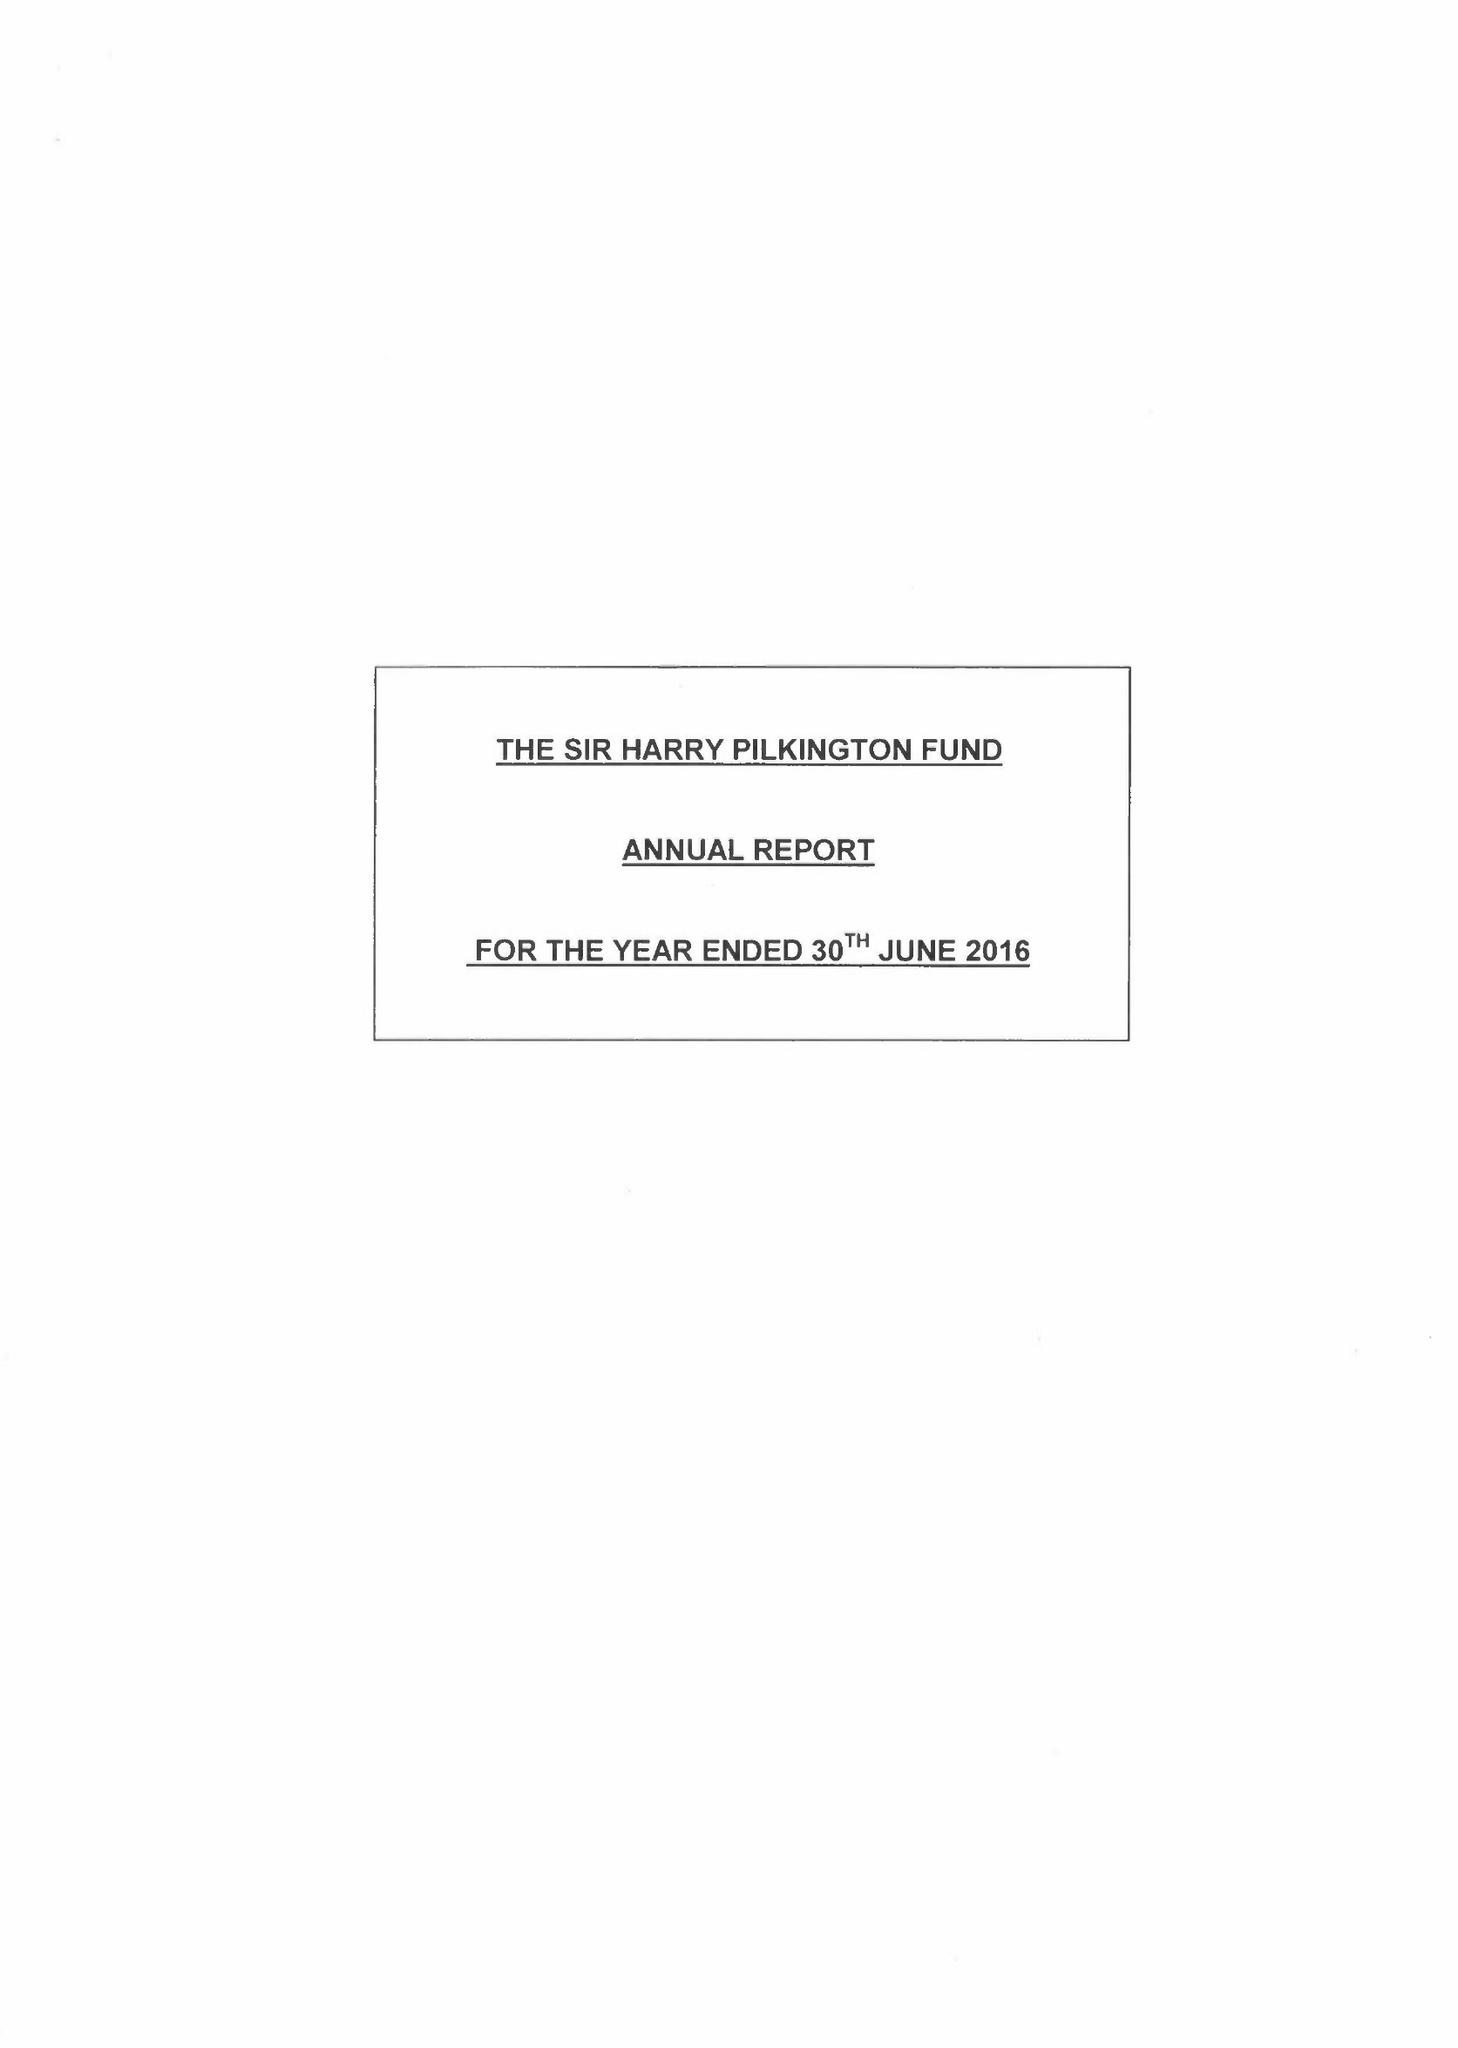What is the value for the charity_name?
Answer the question using a single word or phrase. Sir Harry Pilkington Fund 